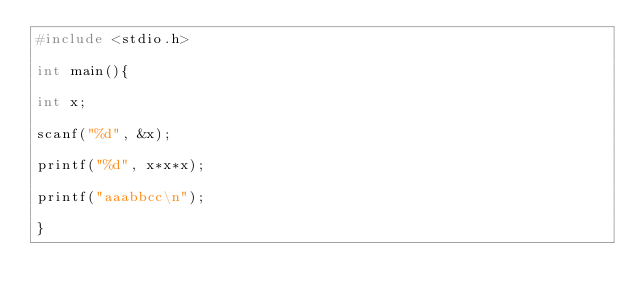<code> <loc_0><loc_0><loc_500><loc_500><_C_>#include <stdio.h>

int main(){

int x;

scanf("%d", &x);

printf("%d", x*x*x);

printf("aaabbcc\n");

}</code> 